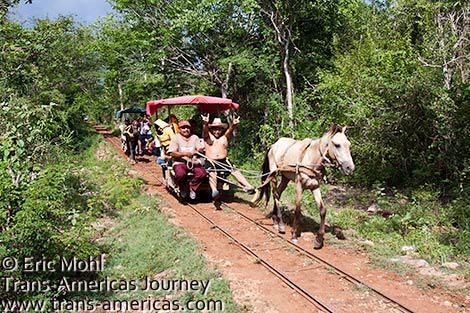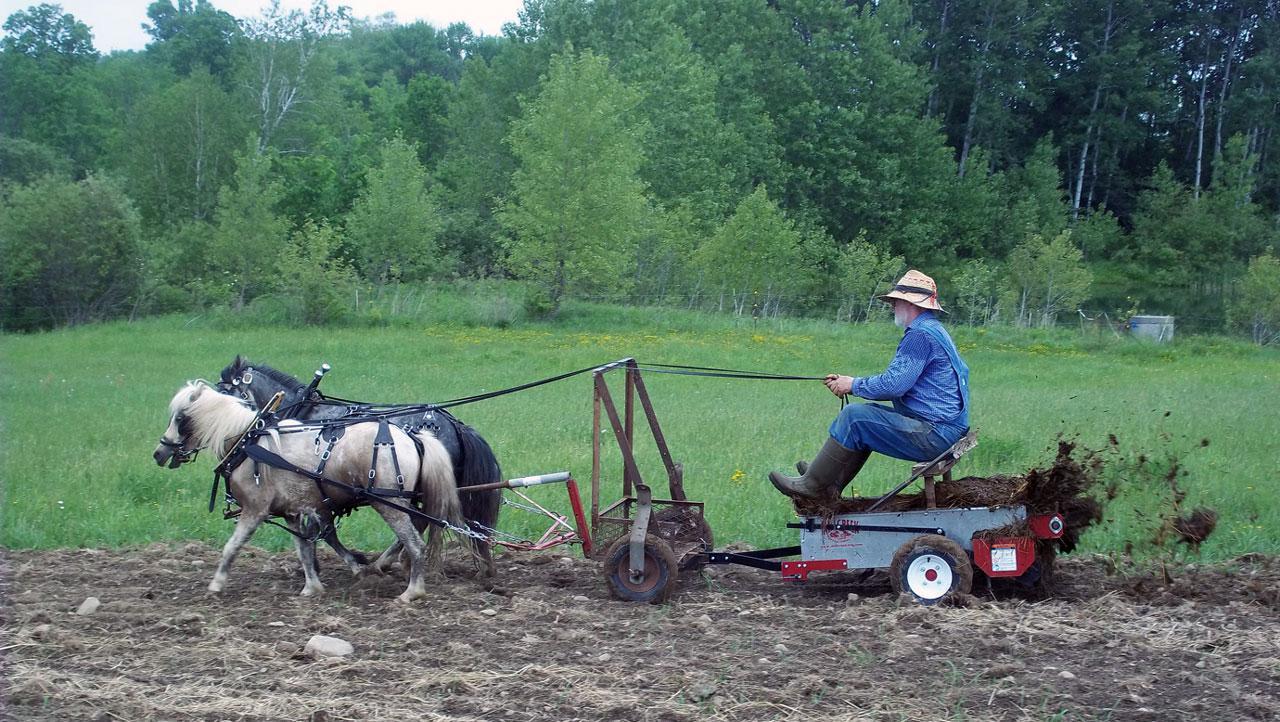The first image is the image on the left, the second image is the image on the right. For the images displayed, is the sentence "In one image, carts with fabric canopies are pulled through the woods along a metal track by a single horse." factually correct? Answer yes or no. Yes. The first image is the image on the left, the second image is the image on the right. Evaluate the accuracy of this statement regarding the images: "At least one image shows a cart pulled by two horses.". Is it true? Answer yes or no. Yes. 